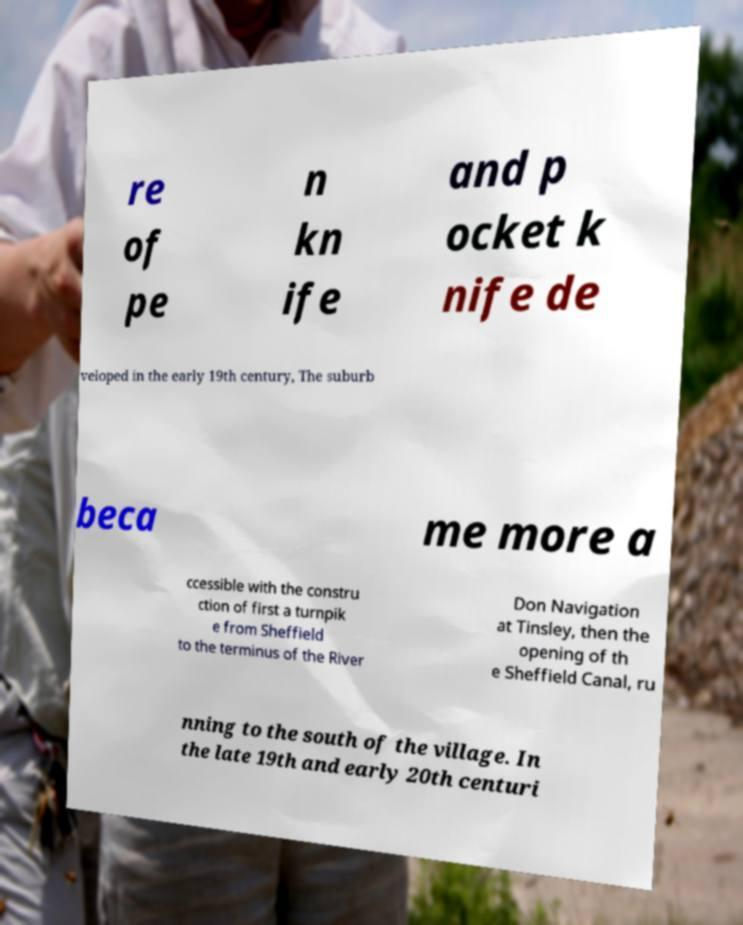Could you extract and type out the text from this image? re of pe n kn ife and p ocket k nife de veloped in the early 19th century, The suburb beca me more a ccessible with the constru ction of first a turnpik e from Sheffield to the terminus of the River Don Navigation at Tinsley, then the opening of th e Sheffield Canal, ru nning to the south of the village. In the late 19th and early 20th centuri 